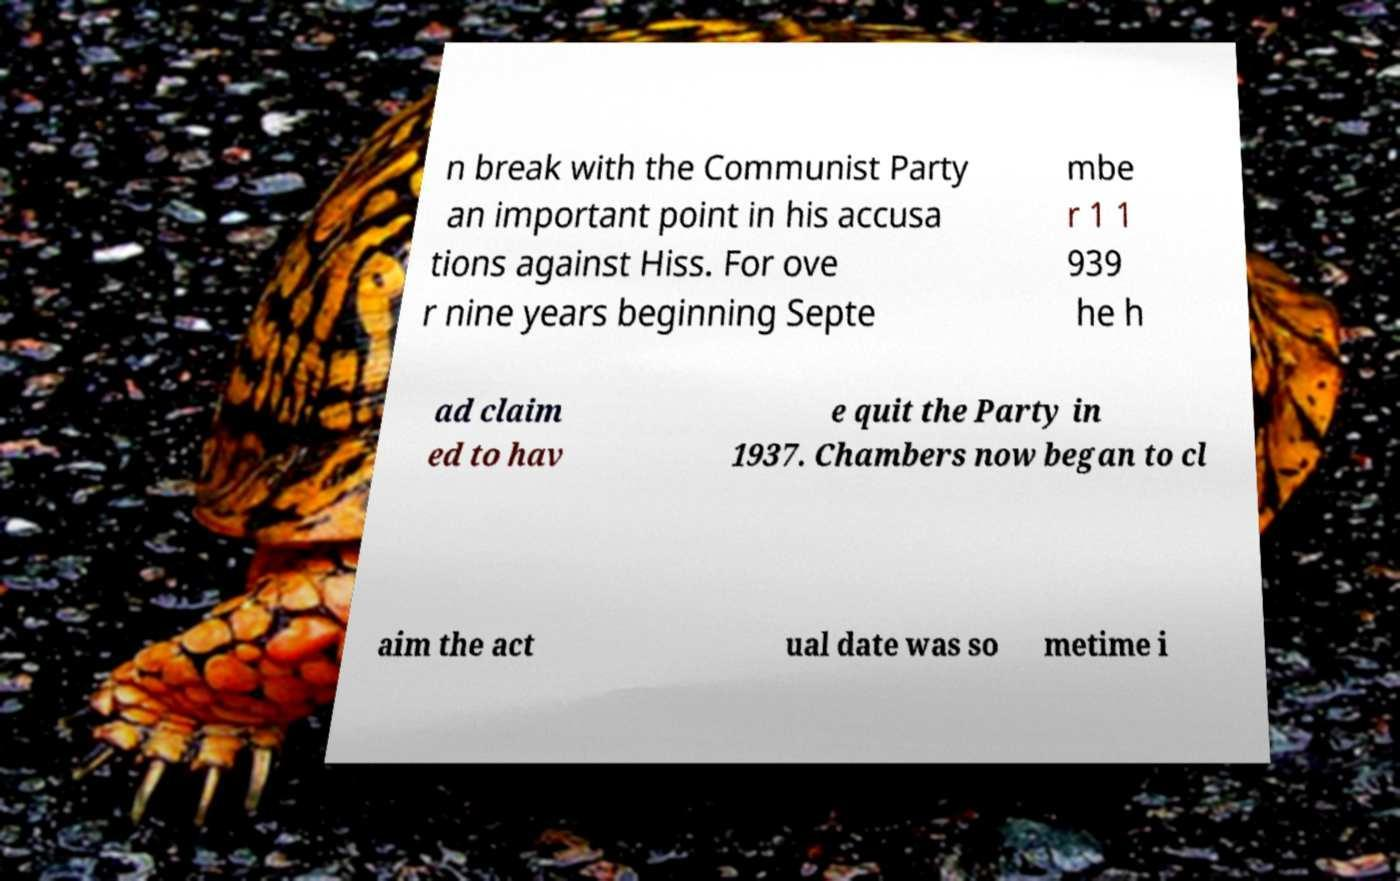For documentation purposes, I need the text within this image transcribed. Could you provide that? n break with the Communist Party an important point in his accusa tions against Hiss. For ove r nine years beginning Septe mbe r 1 1 939 he h ad claim ed to hav e quit the Party in 1937. Chambers now began to cl aim the act ual date was so metime i 